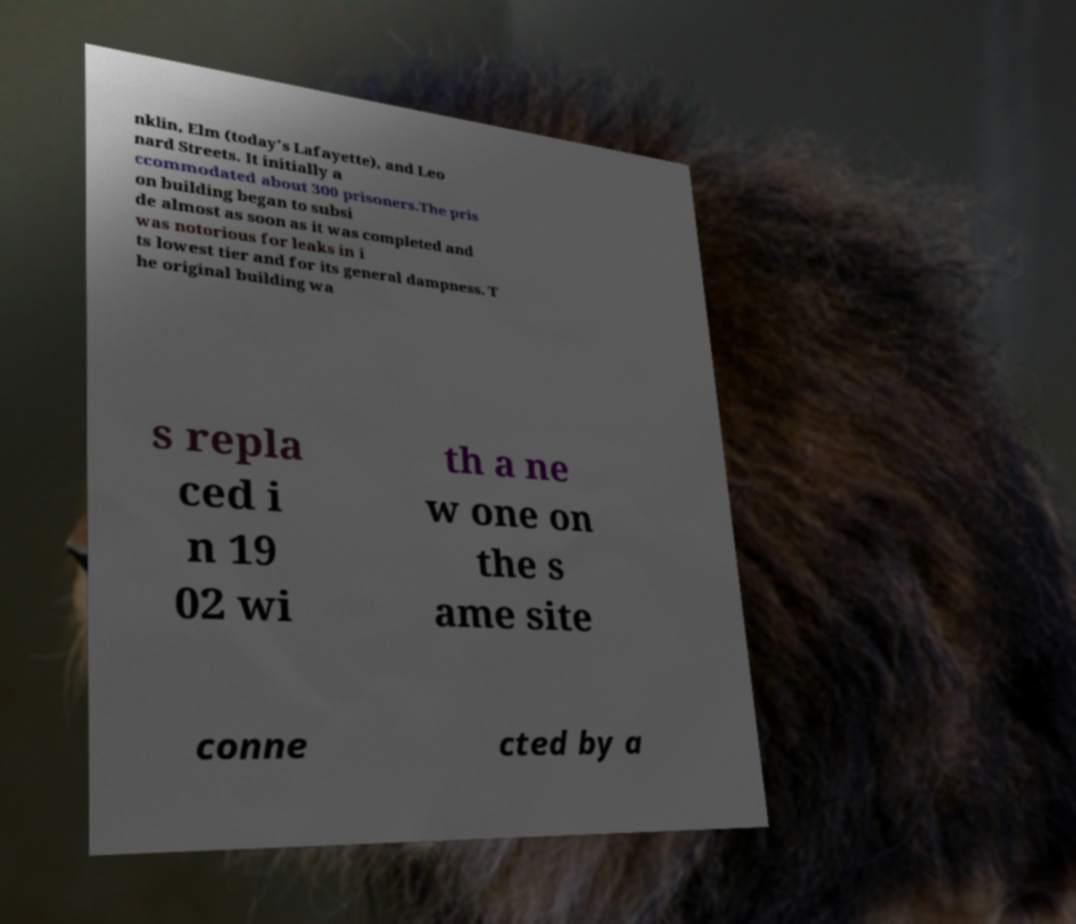Can you read and provide the text displayed in the image?This photo seems to have some interesting text. Can you extract and type it out for me? nklin, Elm (today's Lafayette), and Leo nard Streets. It initially a ccommodated about 300 prisoners.The pris on building began to subsi de almost as soon as it was completed and was notorious for leaks in i ts lowest tier and for its general dampness. T he original building wa s repla ced i n 19 02 wi th a ne w one on the s ame site conne cted by a 